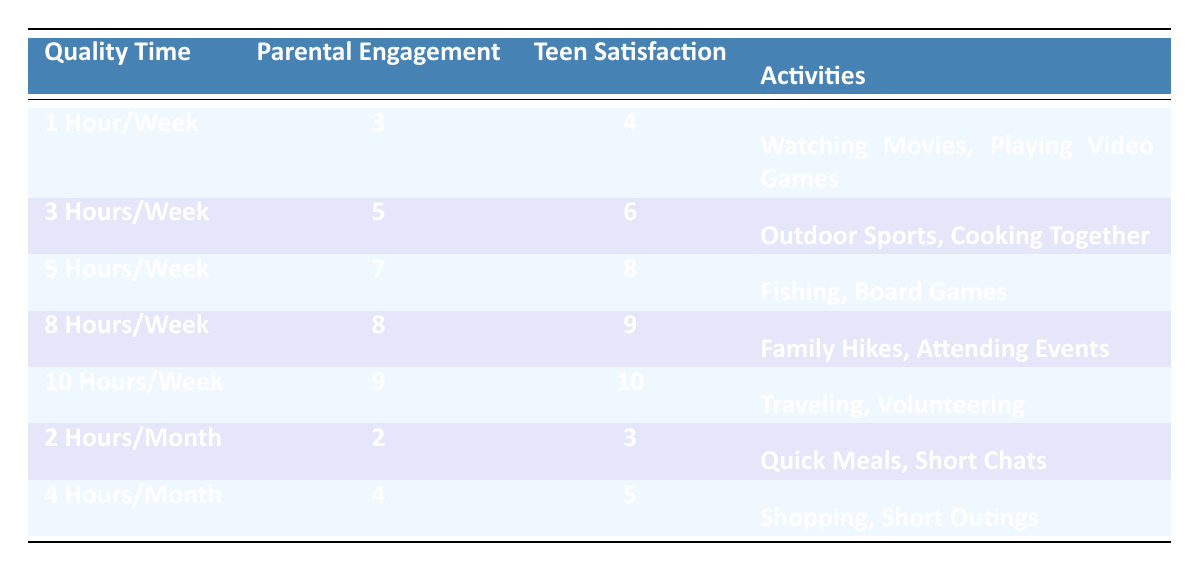What is the highest Parental Engagement Score in the table? The highest Parental Engagement Score listed is 9, which corresponds to the entry for "10 Hours per Week."
Answer: 9 What activities were engaged in for the entry with 8 hours of quality time spent? The activities listed for "8 Hours per Week" are "Family Hikes" and "Attending Events."
Answer: Family Hikes, Attending Events Is the Teen Satisfaction Score higher when more quality time is spent? Yes, as observed in the data, the Teen Satisfaction Score increases with the amount of quality time, indicating a positive correlation.
Answer: Yes What is the difference between the Teen Satisfaction Scores for 1 hour per week and 10 hours per week? The Teen Satisfaction Score for 1 hour per week is 4 and for 10 hours per week is 10. The difference is 10 - 4 = 6.
Answer: 6 What is the average Parental Engagement Score for entries categorized under "Hours per Month"? The entries for "Hours per Month" show scores of 2 (2 Hours/Month) and 4 (4 Hours/Month). The average is (2 + 4)/2 = 3.
Answer: 3 How many activities are listed for the entry with the lowest Teen Satisfaction Score? The entry with the lowest Teen Satisfaction Score (3) for "2 Hours per Month" lists 2 activities: "Quick Meals" and "Short Chats."
Answer: 2 Which Quality Time category has the best combination of Parental Engagement and Teen Satisfaction? The category "10 Hours per Week" has the highest scores of 9 for Parental Engagement and 10 for Teen Satisfaction, making it the best combination.
Answer: 10 Hours per Week What type of activities are common in entries with higher satisfaction scores? Activities such as "Traveling," "Volunteering," and "Family Hikes" are engaged in higher satisfaction score entries, indicating a preference for interactive, engaging activities.
Answer: Interactive Activities What is the total Parental Engagement Score for the entries with 3 hours and 5 hours of quality time? The Parental Engagement Scores for "3 Hours per Week" and "5 Hours per Week" are 5 and 7, respectively. Their sum is 5 + 7 = 12.
Answer: 12 Does spending less time than 2 hours per month correlate with better satisfaction scores? No, entries with less than 2 hours, such as "2 Hours per Month," show lower satisfaction scores compared to those that spend more time together.
Answer: No 